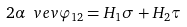<formula> <loc_0><loc_0><loc_500><loc_500>2 \alpha \ v e v { \varphi } _ { 1 2 } = H _ { 1 } \sigma + H _ { 2 } \tau</formula> 